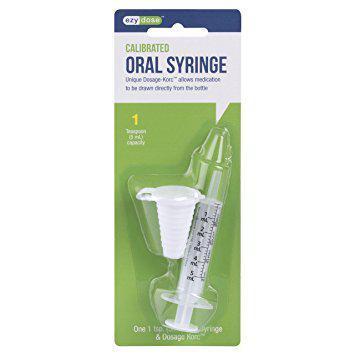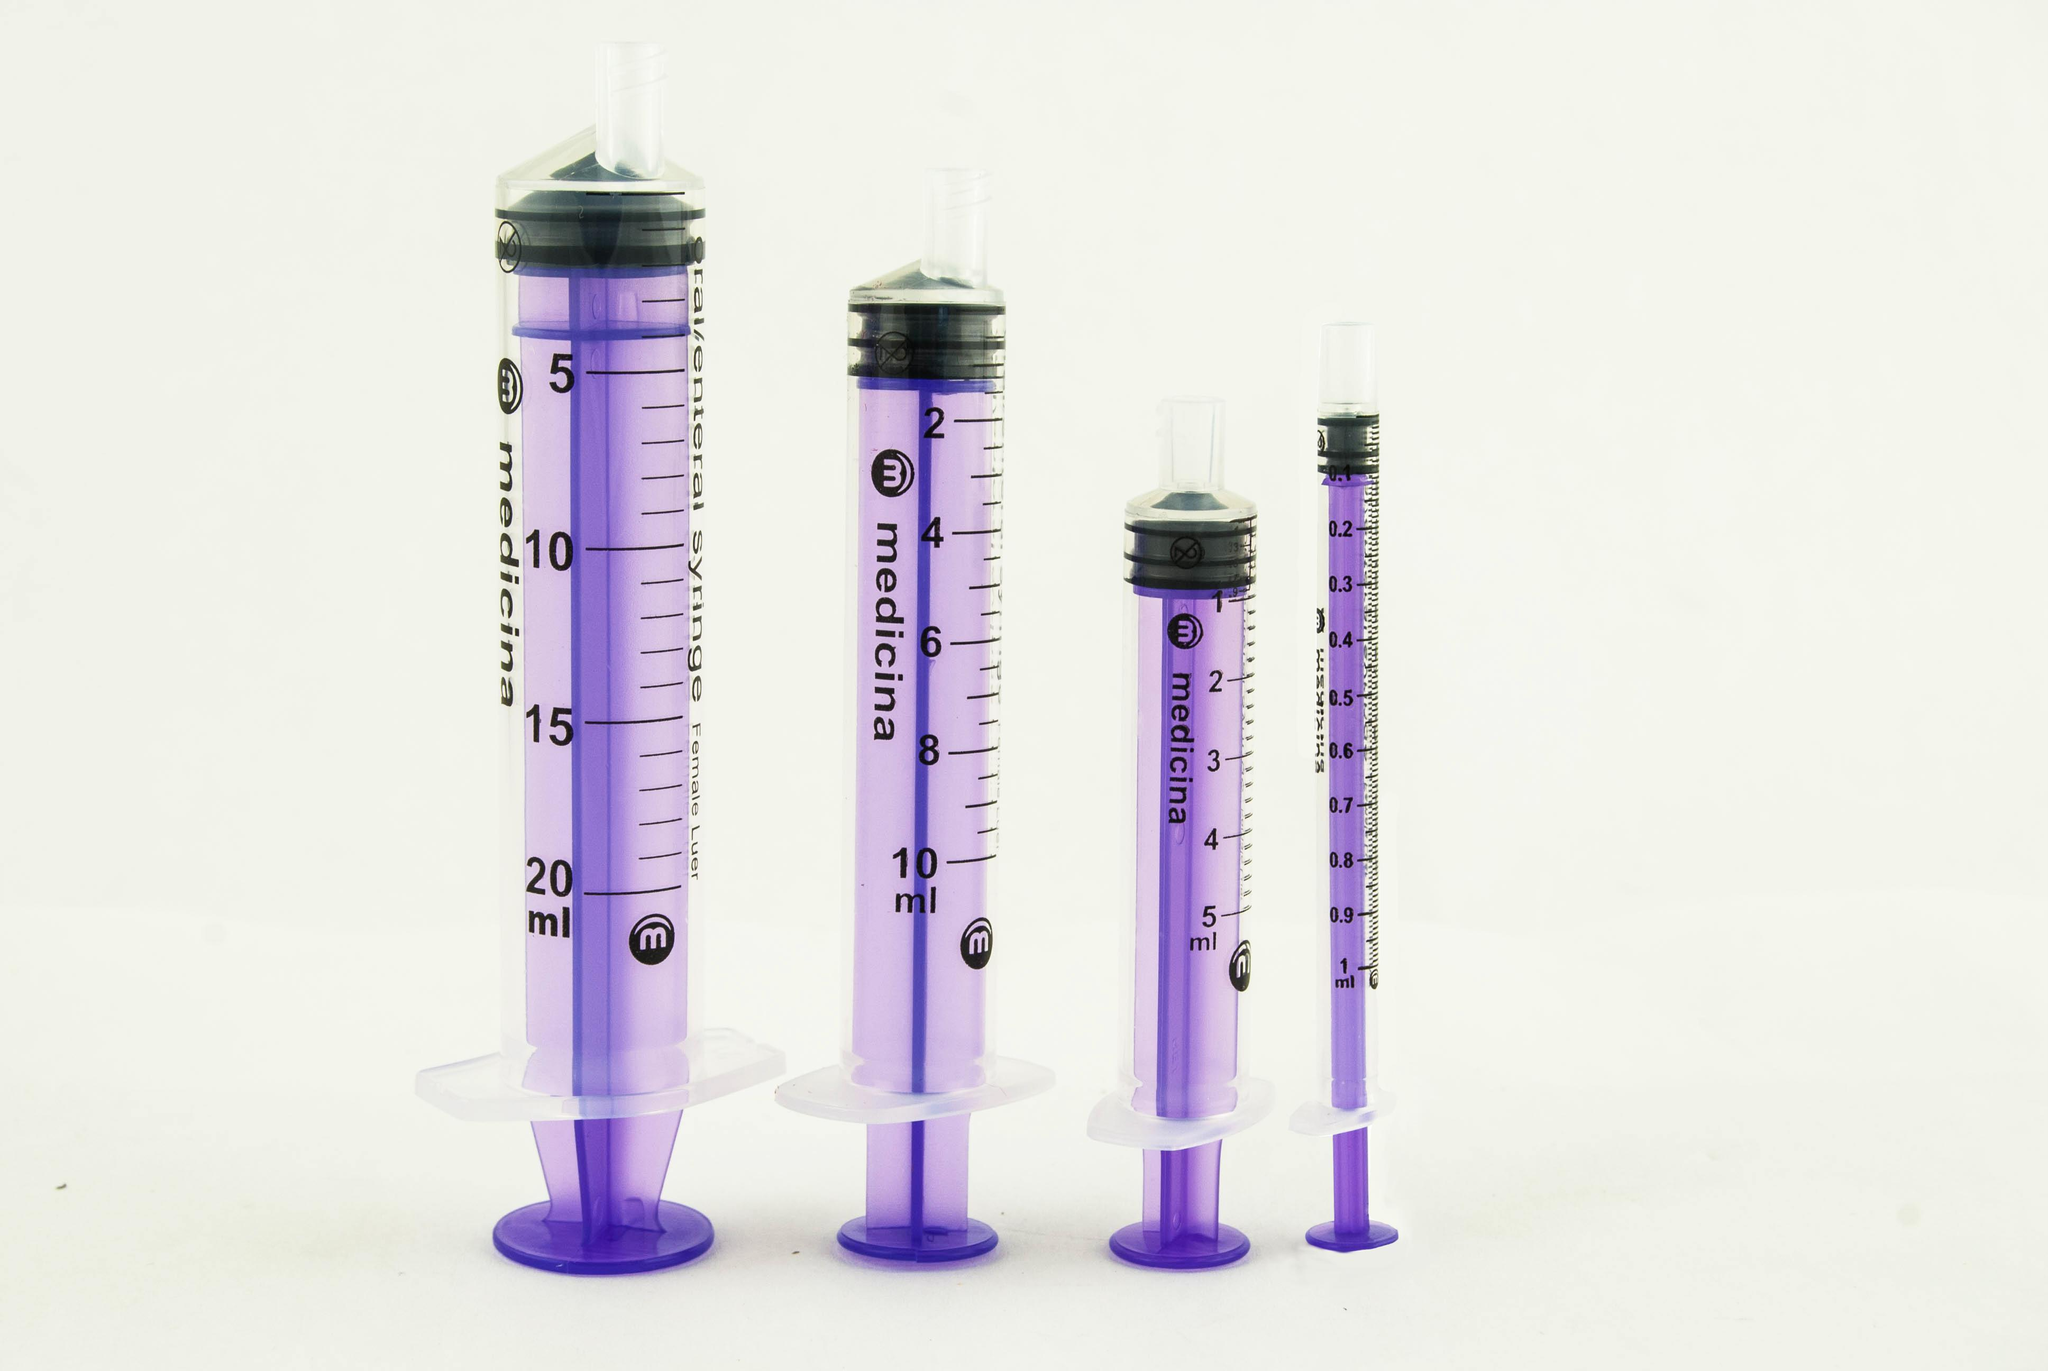The first image is the image on the left, the second image is the image on the right. Given the left and right images, does the statement "At least one image includes an item resembling a pacifier next to a syringe." hold true? Answer yes or no. No. The first image is the image on the left, the second image is the image on the right. Evaluate the accuracy of this statement regarding the images: "The left image has a syringe with a nozzle, the right image has at least three syringes, and no image has a pacifier.". Is it true? Answer yes or no. Yes. 